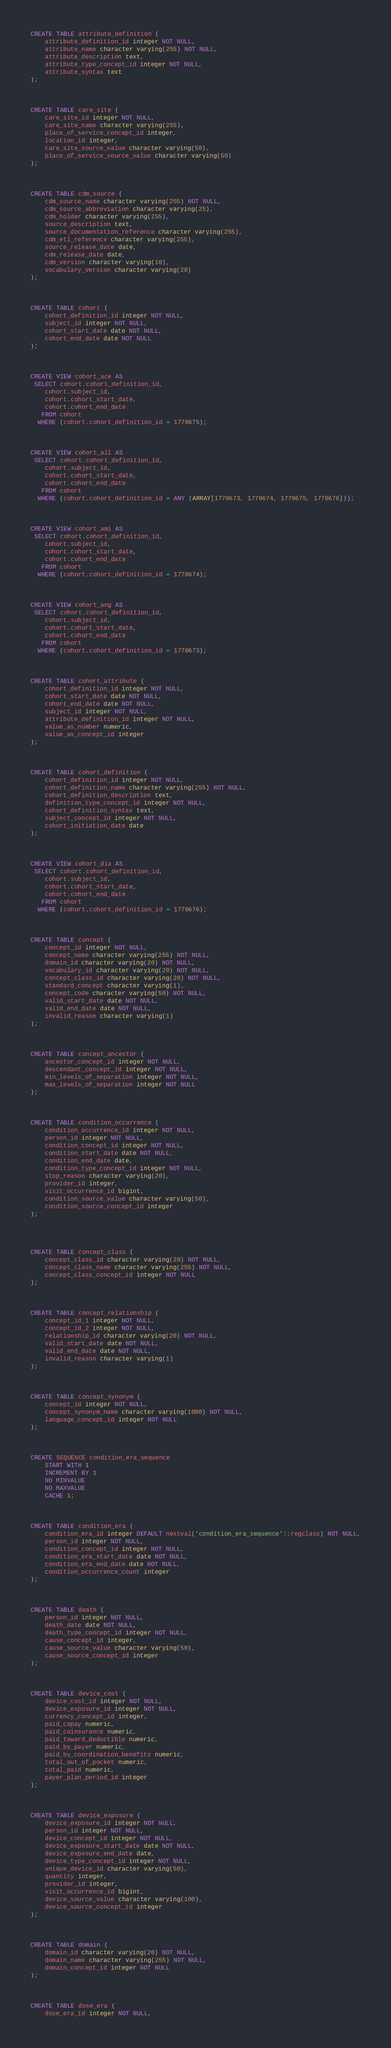Convert code to text. <code><loc_0><loc_0><loc_500><loc_500><_SQL_>


CREATE TABLE attribute_definition (
    attribute_definition_id integer NOT NULL,
    attribute_name character varying(255) NOT NULL,
    attribute_description text,
    attribute_type_concept_id integer NOT NULL,
    attribute_syntax text
);



CREATE TABLE care_site (
    care_site_id integer NOT NULL,
    care_site_name character varying(255),
    place_of_service_concept_id integer,
    location_id integer,
    care_site_source_value character varying(50),
    place_of_service_source_value character varying(50)
);



CREATE TABLE cdm_source (
    cdm_source_name character varying(255) NOT NULL,
    cdm_source_abbreviation character varying(25),
    cdm_holder character varying(255),
    source_description text,
    source_documentation_reference character varying(255),
    cdm_etl_reference character varying(255),
    source_release_date date,
    cdm_release_date date,
    cdm_version character varying(10),
    vocabulary_version character varying(20)
);



CREATE TABLE cohort (
    cohort_definition_id integer NOT NULL,
    subject_id integer NOT NULL,
    cohort_start_date date NOT NULL,
    cohort_end_date date NOT NULL
);



CREATE VIEW cohort_ace AS
 SELECT cohort.cohort_definition_id,
    cohort.subject_id,
    cohort.cohort_start_date,
    cohort.cohort_end_date
   FROM cohort
  WHERE (cohort.cohort_definition_id = 1770675);



CREATE VIEW cohort_all AS
 SELECT cohort.cohort_definition_id,
    cohort.subject_id,
    cohort.cohort_start_date,
    cohort.cohort_end_date
   FROM cohort
  WHERE (cohort.cohort_definition_id = ANY (ARRAY[1770673, 1770674, 1770675, 1770676]));



CREATE VIEW cohort_ami AS
 SELECT cohort.cohort_definition_id,
    cohort.subject_id,
    cohort.cohort_start_date,
    cohort.cohort_end_date
   FROM cohort
  WHERE (cohort.cohort_definition_id = 1770674);



CREATE VIEW cohort_ang AS
 SELECT cohort.cohort_definition_id,
    cohort.subject_id,
    cohort.cohort_start_date,
    cohort.cohort_end_date
   FROM cohort
  WHERE (cohort.cohort_definition_id = 1770673);



CREATE TABLE cohort_attribute (
    cohort_definition_id integer NOT NULL,
    cohort_start_date date NOT NULL,
    cohort_end_date date NOT NULL,
    subject_id integer NOT NULL,
    attribute_definition_id integer NOT NULL,
    value_as_number numeric,
    value_as_concept_id integer
);



CREATE TABLE cohort_definition (
    cohort_definition_id integer NOT NULL,
    cohort_definition_name character varying(255) NOT NULL,
    cohort_definition_description text,
    definition_type_concept_id integer NOT NULL,
    cohort_definition_syntax text,
    subject_concept_id integer NOT NULL,
    cohort_initiation_date date
);



CREATE VIEW cohort_dia AS
 SELECT cohort.cohort_definition_id,
    cohort.subject_id,
    cohort.cohort_start_date,
    cohort.cohort_end_date
   FROM cohort
  WHERE (cohort.cohort_definition_id = 1770676);



CREATE TABLE concept (
    concept_id integer NOT NULL,
    concept_name character varying(255) NOT NULL,
    domain_id character varying(20) NOT NULL,
    vocabulary_id character varying(20) NOT NULL,
    concept_class_id character varying(20) NOT NULL,
    standard_concept character varying(1),
    concept_code character varying(50) NOT NULL,
    valid_start_date date NOT NULL,
    valid_end_date date NOT NULL,
    invalid_reason character varying(1)
);



CREATE TABLE concept_ancestor (
    ancestor_concept_id integer NOT NULL,
    descendant_concept_id integer NOT NULL,
    min_levels_of_separation integer NOT NULL,
    max_levels_of_separation integer NOT NULL
);



CREATE TABLE condition_occurrence (
    condition_occurrence_id integer NOT NULL,
    person_id integer NOT NULL,
    condition_concept_id integer NOT NULL,
    condition_start_date date NOT NULL,
    condition_end_date date,
    condition_type_concept_id integer NOT NULL,
    stop_reason character varying(20),
    provider_id integer,
    visit_occurrence_id bigint,
    condition_source_value character varying(50),
    condition_source_concept_id integer
);




CREATE TABLE concept_class (
    concept_class_id character varying(20) NOT NULL,
    concept_class_name character varying(255) NOT NULL,
    concept_class_concept_id integer NOT NULL
);



CREATE TABLE concept_relationship (
    concept_id_1 integer NOT NULL,
    concept_id_2 integer NOT NULL,
    relationship_id character varying(20) NOT NULL,
    valid_start_date date NOT NULL,
    valid_end_date date NOT NULL,
    invalid_reason character varying(1)
);



CREATE TABLE concept_synonym (
    concept_id integer NOT NULL,
    concept_synonym_name character varying(1000) NOT NULL,
    language_concept_id integer NOT NULL
);



CREATE SEQUENCE condition_era_sequence
    START WITH 1
    INCREMENT BY 1
    NO MINVALUE
    NO MAXVALUE
    CACHE 1;



CREATE TABLE condition_era (
    condition_era_id integer DEFAULT nextval('condition_era_sequence'::regclass) NOT NULL,
    person_id integer NOT NULL,
    condition_concept_id integer NOT NULL,
    condition_era_start_date date NOT NULL,
    condition_era_end_date date NOT NULL,
    condition_occurrence_count integer
);



CREATE TABLE death (
    person_id integer NOT NULL,
    death_date date NOT NULL,
    death_type_concept_id integer NOT NULL,
    cause_concept_id integer,
    cause_source_value character varying(50),
    cause_source_concept_id integer
);



CREATE TABLE device_cost (
    device_cost_id integer NOT NULL,
    device_exposure_id integer NOT NULL,
    currency_concept_id integer,
    paid_copay numeric,
    paid_coinsurance numeric,
    paid_toward_deductible numeric,
    paid_by_payer numeric,
    paid_by_coordination_benefits numeric,
    total_out_of_pocket numeric,
    total_paid numeric,
    payer_plan_period_id integer
);



CREATE TABLE device_exposure (
    device_exposure_id integer NOT NULL,
    person_id integer NOT NULL,
    device_concept_id integer NOT NULL,
    device_exposure_start_date date NOT NULL,
    device_exposure_end_date date,
    device_type_concept_id integer NOT NULL,
    unique_device_id character varying(50),
    quantity integer,
    provider_id integer,
    visit_occurrence_id bigint,
    device_source_value character varying(100),
    device_source_concept_id integer
);



CREATE TABLE domain (
    domain_id character varying(20) NOT NULL,
    domain_name character varying(255) NOT NULL,
    domain_concept_id integer NOT NULL
);



CREATE TABLE dose_era (
    dose_era_id integer NOT NULL,</code> 